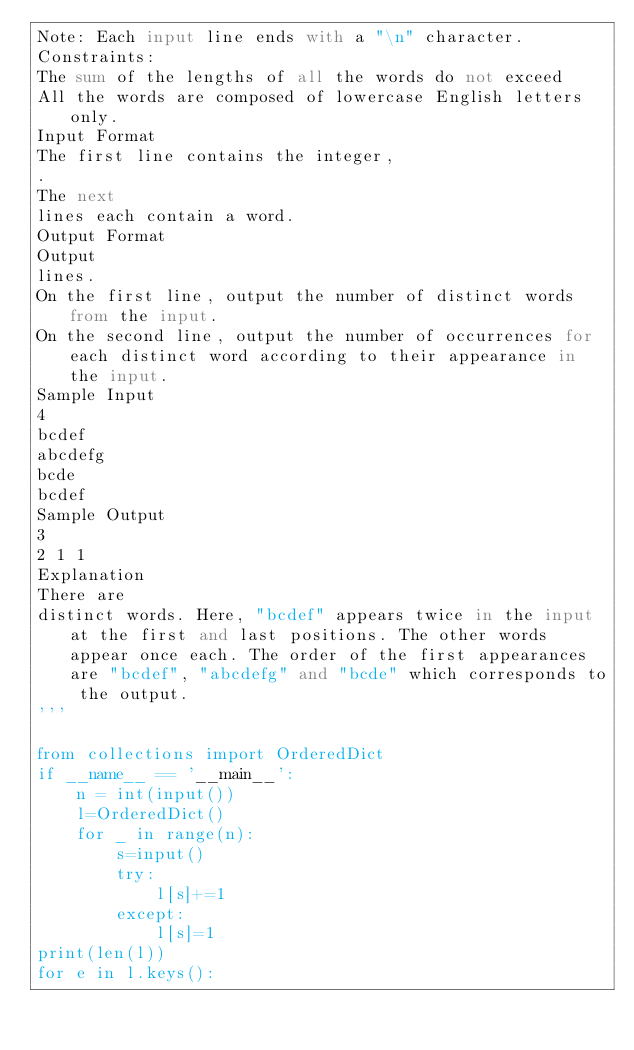Convert code to text. <code><loc_0><loc_0><loc_500><loc_500><_Python_>Note: Each input line ends with a "\n" character.
Constraints:
The sum of the lengths of all the words do not exceed
All the words are composed of lowercase English letters only.
Input Format
The first line contains the integer,
.
The next
lines each contain a word.
Output Format
Output
lines.
On the first line, output the number of distinct words from the input.
On the second line, output the number of occurrences for each distinct word according to their appearance in the input.
Sample Input
4
bcdef
abcdefg
bcde
bcdef
Sample Output
3
2 1 1
Explanation
There are
distinct words. Here, "bcdef" appears twice in the input at the first and last positions. The other words appear once each. The order of the first appearances are "bcdef", "abcdefg" and "bcde" which corresponds to the output.
'''

from collections import OrderedDict
if __name__ == '__main__':
    n = int(input())
    l=OrderedDict()
    for _ in range(n):
        s=input()
        try:
            l[s]+=1
        except:
            l[s]=1
print(len(l))
for e in l.keys():
</code> 